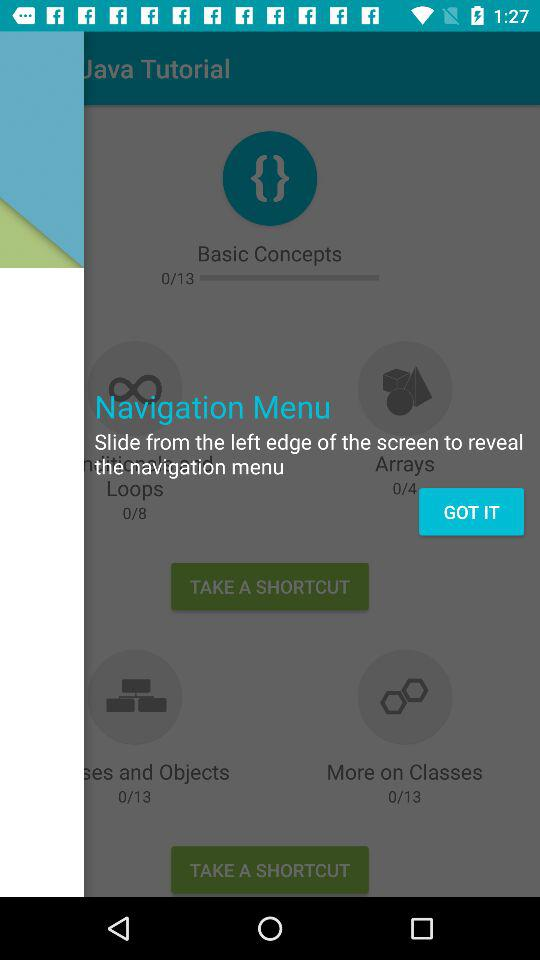How many basic concepts in total are there? There are a total of 13 basic concepts. 